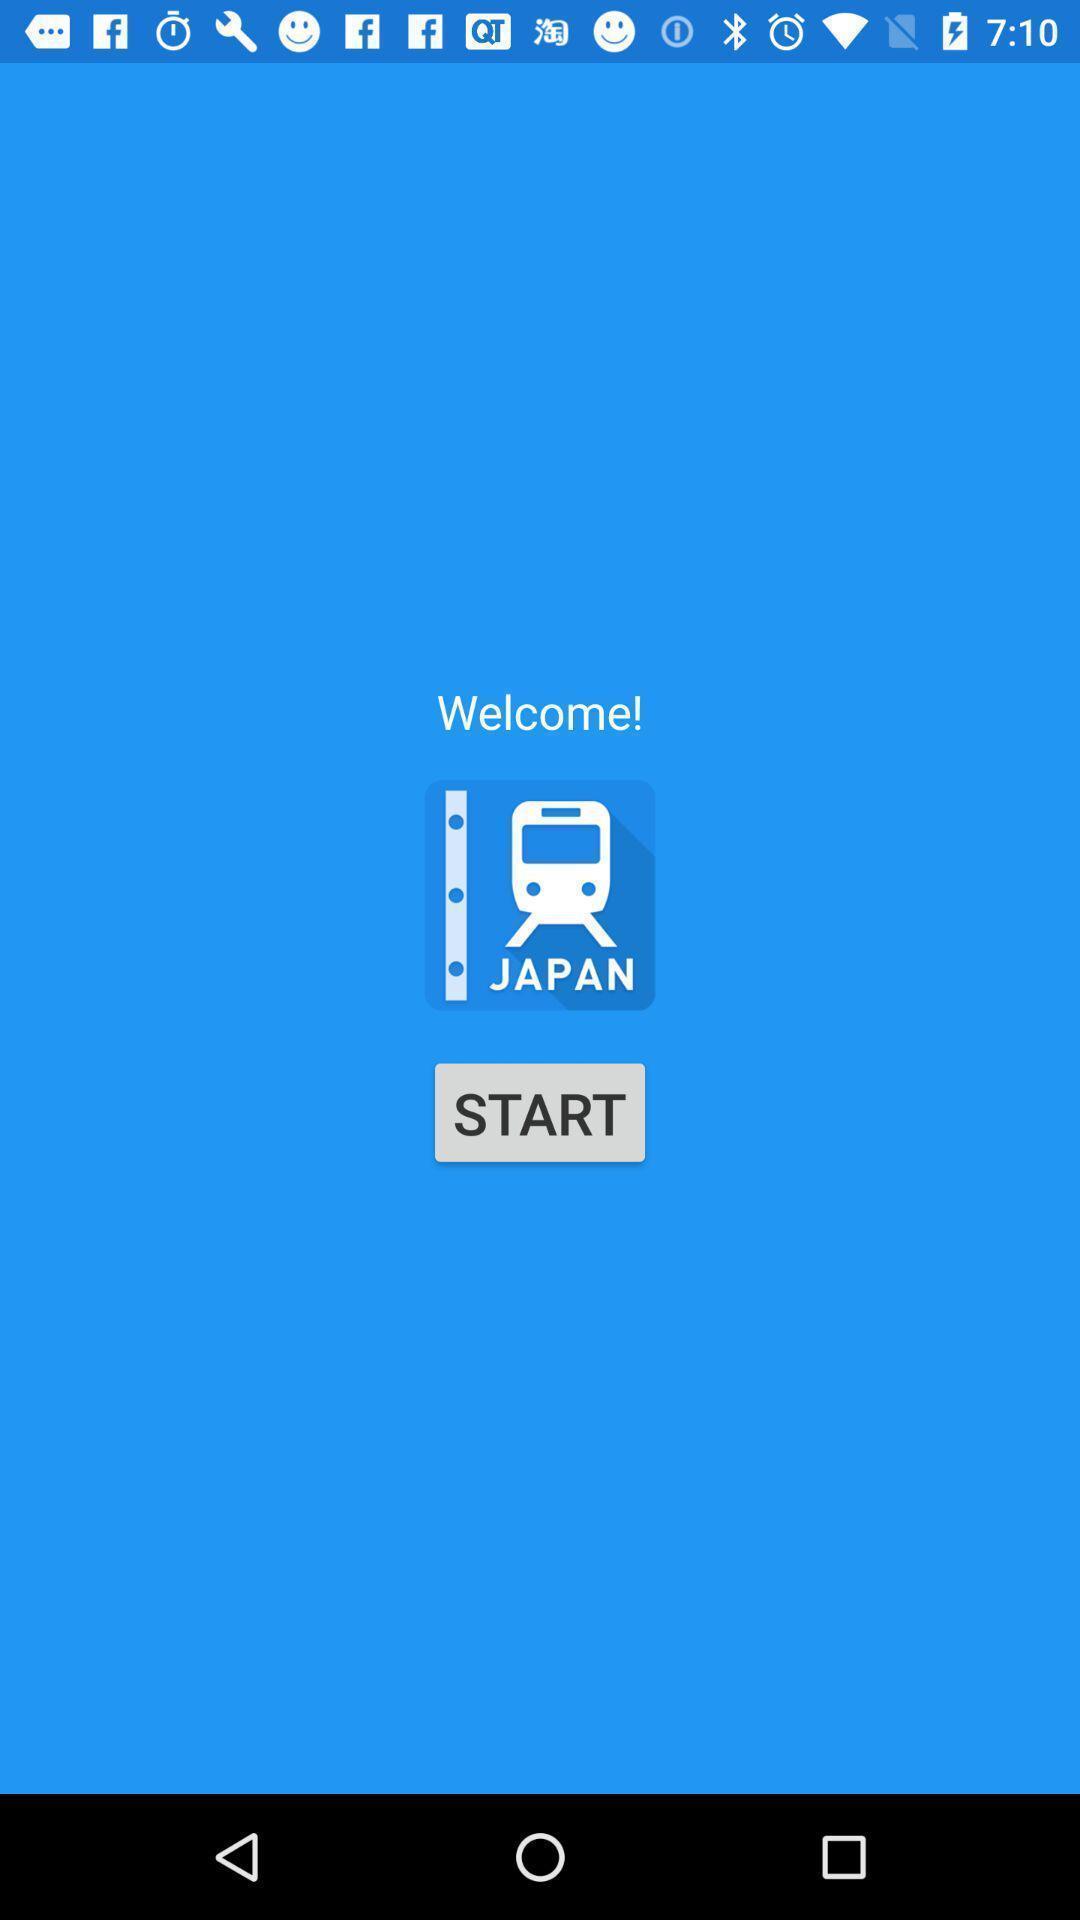Explain the elements present in this screenshot. Welcome page of train details app. 